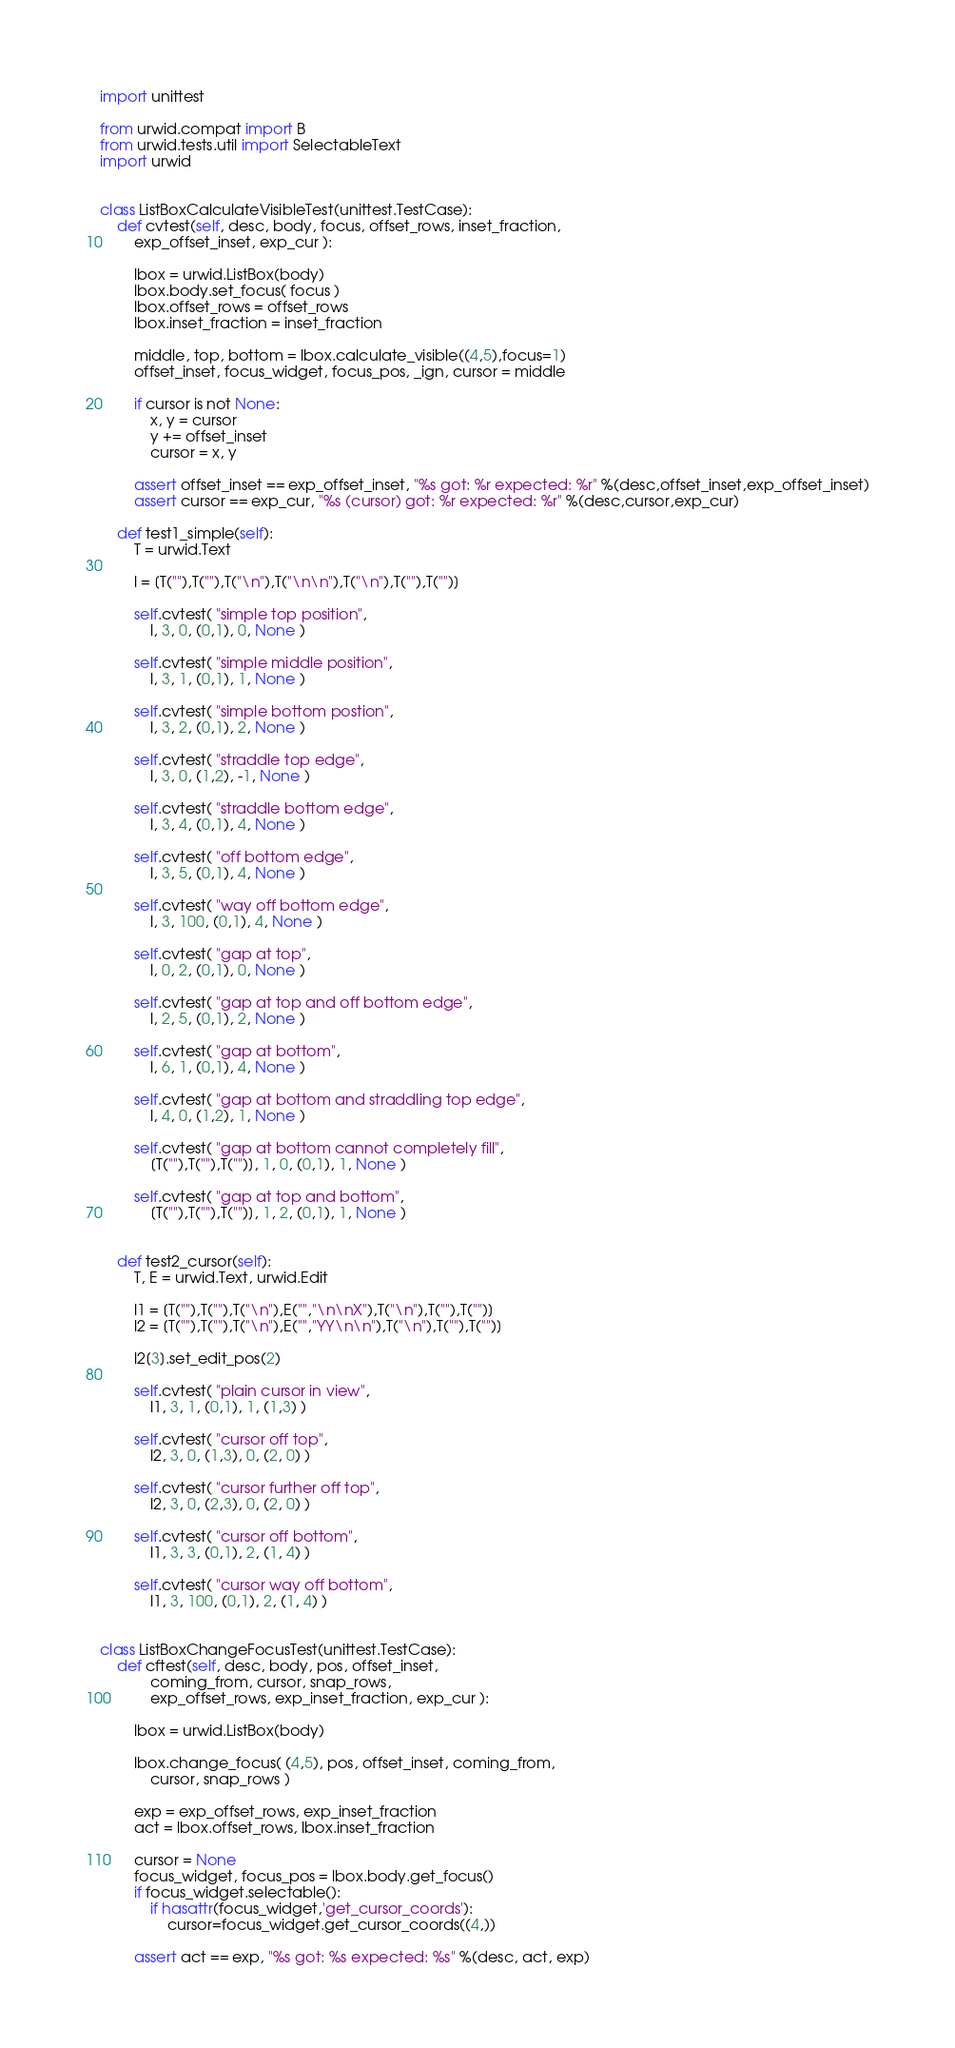Convert code to text. <code><loc_0><loc_0><loc_500><loc_500><_Python_>import unittest

from urwid.compat import B
from urwid.tests.util import SelectableText
import urwid


class ListBoxCalculateVisibleTest(unittest.TestCase):
    def cvtest(self, desc, body, focus, offset_rows, inset_fraction,
        exp_offset_inset, exp_cur ):

        lbox = urwid.ListBox(body)
        lbox.body.set_focus( focus )
        lbox.offset_rows = offset_rows
        lbox.inset_fraction = inset_fraction

        middle, top, bottom = lbox.calculate_visible((4,5),focus=1)
        offset_inset, focus_widget, focus_pos, _ign, cursor = middle

        if cursor is not None:
            x, y = cursor
            y += offset_inset
            cursor = x, y

        assert offset_inset == exp_offset_inset, "%s got: %r expected: %r" %(desc,offset_inset,exp_offset_inset)
        assert cursor == exp_cur, "%s (cursor) got: %r expected: %r" %(desc,cursor,exp_cur)

    def test1_simple(self):
        T = urwid.Text

        l = [T(""),T(""),T("\n"),T("\n\n"),T("\n"),T(""),T("")]

        self.cvtest( "simple top position",
            l, 3, 0, (0,1), 0, None )

        self.cvtest( "simple middle position",
            l, 3, 1, (0,1), 1, None )

        self.cvtest( "simple bottom postion",
            l, 3, 2, (0,1), 2, None )

        self.cvtest( "straddle top edge",
            l, 3, 0, (1,2), -1, None )

        self.cvtest( "straddle bottom edge",
            l, 3, 4, (0,1), 4, None )

        self.cvtest( "off bottom edge",
            l, 3, 5, (0,1), 4, None )

        self.cvtest( "way off bottom edge",
            l, 3, 100, (0,1), 4, None )

        self.cvtest( "gap at top",
            l, 0, 2, (0,1), 0, None )

        self.cvtest( "gap at top and off bottom edge",
            l, 2, 5, (0,1), 2, None )

        self.cvtest( "gap at bottom",
            l, 6, 1, (0,1), 4, None )

        self.cvtest( "gap at bottom and straddling top edge",
            l, 4, 0, (1,2), 1, None )

        self.cvtest( "gap at bottom cannot completely fill",
            [T(""),T(""),T("")], 1, 0, (0,1), 1, None )

        self.cvtest( "gap at top and bottom",
            [T(""),T(""),T("")], 1, 2, (0,1), 1, None )


    def test2_cursor(self):
        T, E = urwid.Text, urwid.Edit

        l1 = [T(""),T(""),T("\n"),E("","\n\nX"),T("\n"),T(""),T("")]
        l2 = [T(""),T(""),T("\n"),E("","YY\n\n"),T("\n"),T(""),T("")]

        l2[3].set_edit_pos(2)

        self.cvtest( "plain cursor in view",
            l1, 3, 1, (0,1), 1, (1,3) )

        self.cvtest( "cursor off top",
            l2, 3, 0, (1,3), 0, (2, 0) )

        self.cvtest( "cursor further off top",
            l2, 3, 0, (2,3), 0, (2, 0) )

        self.cvtest( "cursor off bottom",
            l1, 3, 3, (0,1), 2, (1, 4) )

        self.cvtest( "cursor way off bottom",
            l1, 3, 100, (0,1), 2, (1, 4) )


class ListBoxChangeFocusTest(unittest.TestCase):
    def cftest(self, desc, body, pos, offset_inset,
            coming_from, cursor, snap_rows,
            exp_offset_rows, exp_inset_fraction, exp_cur ):

        lbox = urwid.ListBox(body)

        lbox.change_focus( (4,5), pos, offset_inset, coming_from,
            cursor, snap_rows )

        exp = exp_offset_rows, exp_inset_fraction
        act = lbox.offset_rows, lbox.inset_fraction

        cursor = None
        focus_widget, focus_pos = lbox.body.get_focus()
        if focus_widget.selectable():
            if hasattr(focus_widget,'get_cursor_coords'):
                cursor=focus_widget.get_cursor_coords((4,))

        assert act == exp, "%s got: %s expected: %s" %(desc, act, exp)</code> 